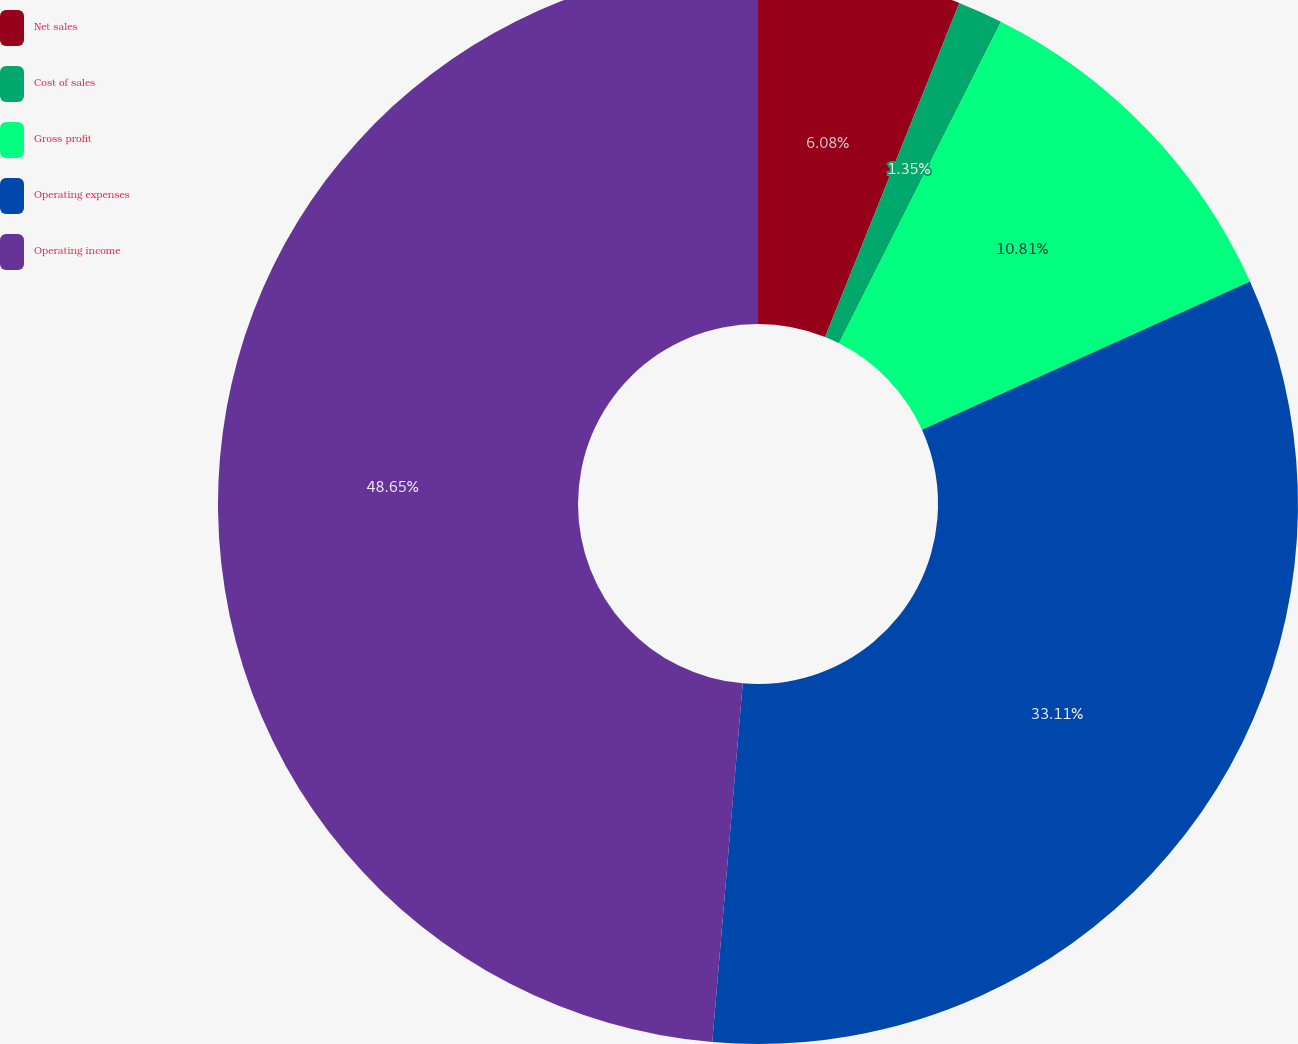Convert chart to OTSL. <chart><loc_0><loc_0><loc_500><loc_500><pie_chart><fcel>Net sales<fcel>Cost of sales<fcel>Gross profit<fcel>Operating expenses<fcel>Operating income<nl><fcel>6.08%<fcel>1.35%<fcel>10.81%<fcel>33.11%<fcel>48.65%<nl></chart> 